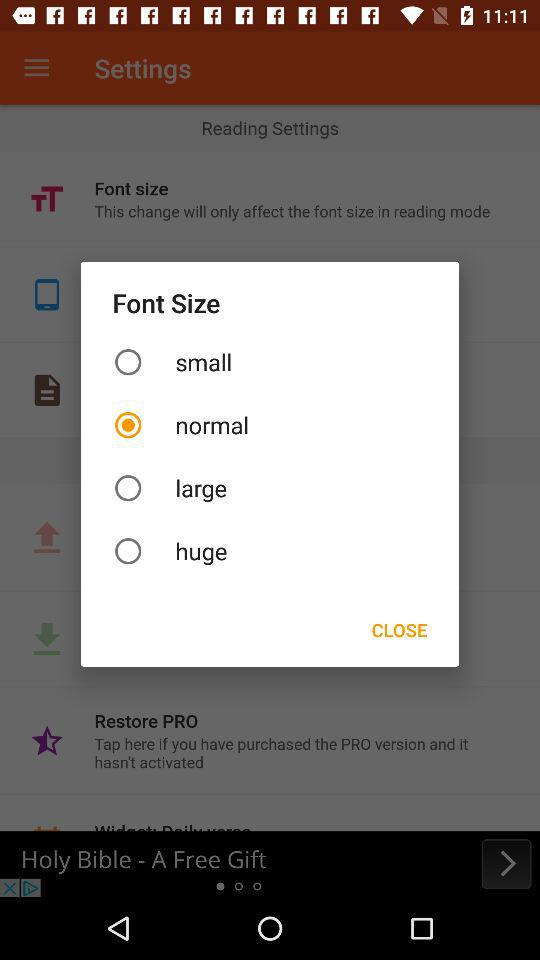What are the given options for font size? The given options for font size are "small", "normal", "large" and "huge". 